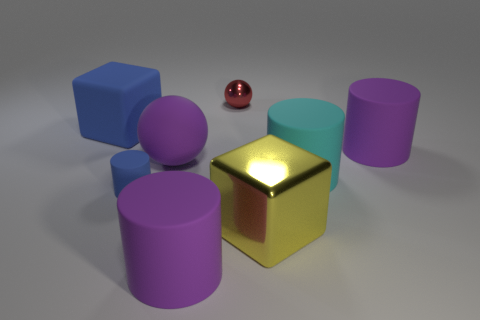How many big cylinders are in front of the blue rubber cylinder and behind the purple matte sphere?
Provide a succinct answer. 0. How many other objects are the same size as the yellow thing?
Offer a terse response. 5. There is a large object that is both behind the tiny blue rubber cylinder and in front of the big matte ball; what is it made of?
Your answer should be very brief. Rubber. There is a small rubber cylinder; is it the same color as the cylinder that is in front of the blue cylinder?
Your answer should be compact. No. There is a yellow thing that is the same shape as the large blue rubber object; what is its size?
Ensure brevity in your answer.  Large. What shape is the rubber thing that is behind the large purple ball and to the left of the large rubber sphere?
Ensure brevity in your answer.  Cube. Do the red metal sphere and the matte cylinder that is behind the large cyan matte cylinder have the same size?
Keep it short and to the point. No. The matte object that is the same shape as the yellow metal object is what color?
Offer a terse response. Blue. Does the sphere that is behind the purple rubber ball have the same size as the purple matte thing right of the yellow thing?
Ensure brevity in your answer.  No. Is the small red object the same shape as the large blue object?
Give a very brief answer. No. 